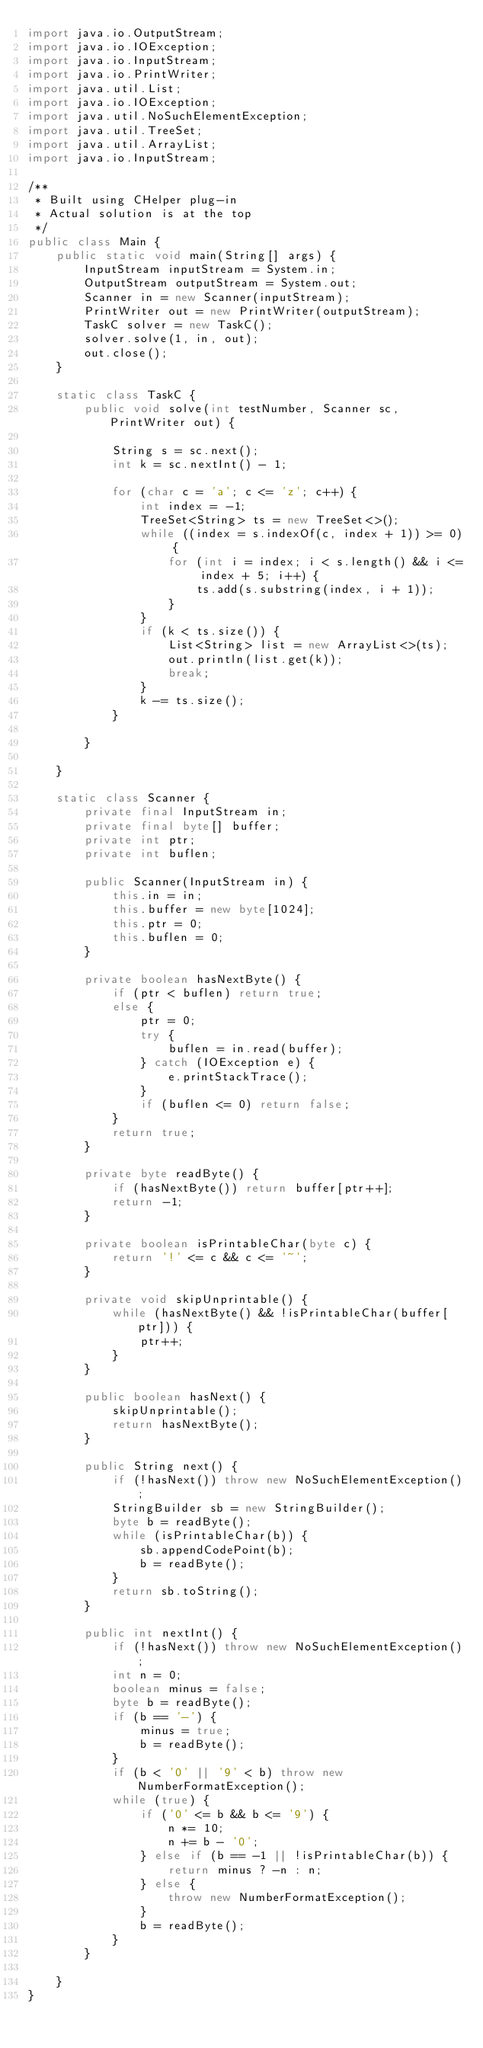<code> <loc_0><loc_0><loc_500><loc_500><_Java_>import java.io.OutputStream;
import java.io.IOException;
import java.io.InputStream;
import java.io.PrintWriter;
import java.util.List;
import java.io.IOException;
import java.util.NoSuchElementException;
import java.util.TreeSet;
import java.util.ArrayList;
import java.io.InputStream;

/**
 * Built using CHelper plug-in
 * Actual solution is at the top
 */
public class Main {
	public static void main(String[] args) {
		InputStream inputStream = System.in;
		OutputStream outputStream = System.out;
		Scanner in = new Scanner(inputStream);
		PrintWriter out = new PrintWriter(outputStream);
		TaskC solver = new TaskC();
		solver.solve(1, in, out);
		out.close();
	}

	static class TaskC {
		public void solve(int testNumber, Scanner sc, PrintWriter out) {

			String s = sc.next();
			int k = sc.nextInt() - 1;

			for (char c = 'a'; c <= 'z'; c++) {
				int index = -1;
				TreeSet<String> ts = new TreeSet<>();
				while ((index = s.indexOf(c, index + 1)) >= 0) {
					for (int i = index; i < s.length() && i <= index + 5; i++) {
						ts.add(s.substring(index, i + 1));
					}
				}
				if (k < ts.size()) {
					List<String> list = new ArrayList<>(ts);
					out.println(list.get(k));
					break;
				}
				k -= ts.size();
			}

		}

	}

	static class Scanner {
		private final InputStream in;
		private final byte[] buffer;
		private int ptr;
		private int buflen;

		public Scanner(InputStream in) {
			this.in = in;
			this.buffer = new byte[1024];
			this.ptr = 0;
			this.buflen = 0;
		}

		private boolean hasNextByte() {
			if (ptr < buflen) return true;
			else {
				ptr = 0;
				try {
					buflen = in.read(buffer);
				} catch (IOException e) {
					e.printStackTrace();
				}
				if (buflen <= 0) return false;
			}
			return true;
		}

		private byte readByte() {
			if (hasNextByte()) return buffer[ptr++];
			return -1;
		}

		private boolean isPrintableChar(byte c) {
			return '!' <= c && c <= '~';
		}

		private void skipUnprintable() {
			while (hasNextByte() && !isPrintableChar(buffer[ptr])) {
				ptr++;
			}
		}

		public boolean hasNext() {
			skipUnprintable();
			return hasNextByte();
		}

		public String next() {
			if (!hasNext()) throw new NoSuchElementException();
			StringBuilder sb = new StringBuilder();
			byte b = readByte();
			while (isPrintableChar(b)) {
				sb.appendCodePoint(b);
				b = readByte();
			}
			return sb.toString();
		}

		public int nextInt() {
			if (!hasNext()) throw new NoSuchElementException();
			int n = 0;
			boolean minus = false;
			byte b = readByte();
			if (b == '-') {
				minus = true;
				b = readByte();
			}
			if (b < '0' || '9' < b) throw new NumberFormatException();
			while (true) {
				if ('0' <= b && b <= '9') {
					n *= 10;
					n += b - '0';
				} else if (b == -1 || !isPrintableChar(b)) {
					return minus ? -n : n;
				} else {
					throw new NumberFormatException();
				}
				b = readByte();
			}
		}

	}
}

</code> 